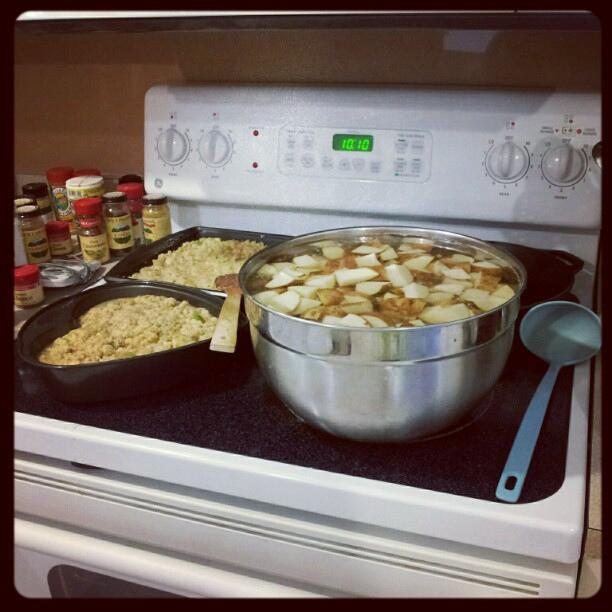Storing the items in the water prevents them from what? oxidizing 